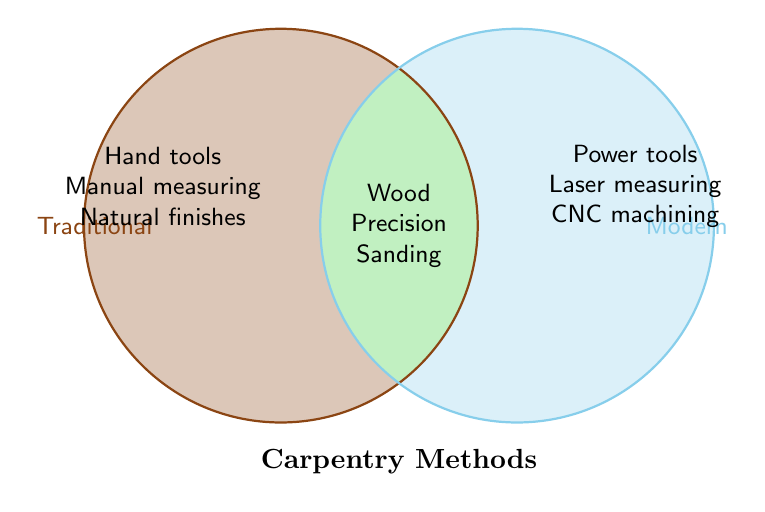What are two methods specific to Traditional carpentry mentioned in the figure? According to the Venn Diagram, methods specific to Traditional carpentry include "Hand tools" and "Manual measuring".
Answer: Hand tools, Manual measuring What elements are shared between Traditional and Modern carpentry methods? The shared elements are in the overlapping section of the Venn Diagram, namely "Wood", "Precision", and "Sanding".
Answer: Wood, Precision, Sanding Which type of measuring technique is exclusive to Modern carpentry? The Venn Diagram shows that "Laser measuring" is listed under the Modern section.
Answer: Laser measuring Which carpentry method uses "Natural finishes"? The Venn Diagram indicates that "Natural finishes" is listed under Traditional carpentry methods.
Answer: Traditional Compare the finishing techniques of Traditional and Modern carpentry methods. Traditional carpentry uses "Natural finishes" while Modern carpentry uses "Synthetic finishes".
Answer: Natural finishes vs. Synthetic finishes Identify one method exclusive to Modern carpentry involving machines. According to the Venn Diagram, "CNC machining" is specific to Modern carpentry.
Answer: CNC machining What is the title of the Venn Diagram? The title of the Venn Diagram is given at the bottom, which is "Carpentry Methods".
Answer: Carpentry Methods Do Traditional carpentry methods use power tools? The Venn Diagram does not list "Power tools" under Traditional carpentry; it lists them under Modern carpentry methods.
Answer: No Explain the relationship between Traditional and Modern carpentry in terms of material sourcing. Traditional carpentry methods use "Local wood sourcing" while Modern methods involve "Global wood imports"; both emphasize "Sustainable materials".
Answer: Local wood sourcing vs. Global wood imports, with both valuing sustainable materials 